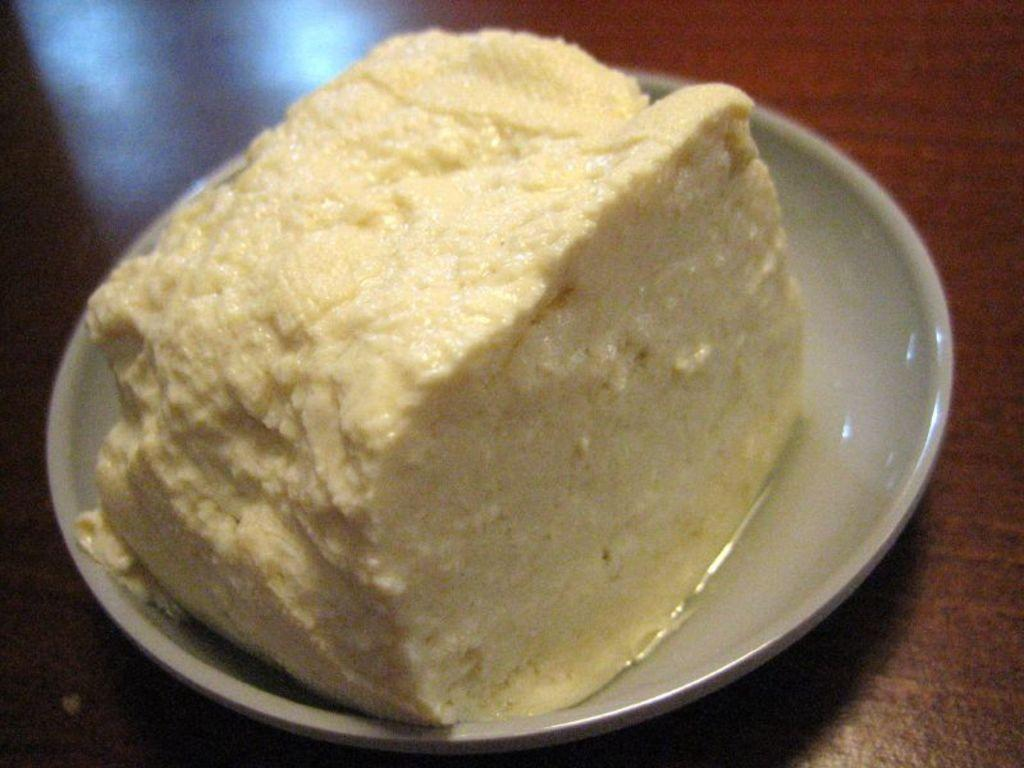What is the main subject of the image? There is a food item in the image. How is the food item presented? The food item is on a plate. What type of surface is the plate resting on? The plate is on a wooden surface. What type of verse is recited by the food item in the image? There is no verse being recited by the food item in the image, as it is an inanimate object. 